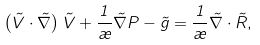Convert formula to latex. <formula><loc_0><loc_0><loc_500><loc_500>\left ( { \vec { V } } \cdot { \vec { \nabla } } \right ) { \vec { V } } + \frac { 1 } { \rho } { \vec { \nabla } } P - { \vec { g } } = \frac { 1 } { \rho } { \vec { \nabla } } \cdot { \vec { R } } ,</formula> 